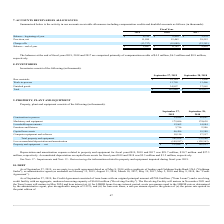According to Macom Technology's financial document, What was the depreciation and amortization expense related to property and equipment for 2019? According to the financial document, $29.7 million. The relevant text states: "equipment for fiscal years 2019, 2018 and 2017 was $29.7 million, $30.7 million and $27.3..." Also, What was the respective value of construction in process in 2019 and 2018? The document shows two values: 24,848 and 49,661 (in thousands). From the document: "Construction in process 24,848 49,661 Construction in process 24,848 49,661..." Also, What was the value of Machinery and equipment in 2019? According to the financial document, 175,696 (in thousands). The relevant text states: "Machinery and equipment 175,696 174,638..." Additionally, In which year was value of Construction in process less than 30,000 thousands? According to the financial document, 2019. The relevant text states: "2019 2018 2017..." Also, can you calculate: What was the average value of Machinery and equipment for 2018 and 2019? To answer this question, I need to perform calculations using the financial data. The calculation is: (175,696 + 174,638) / 2, which equals 175167 (in thousands). This is based on the information: "Machinery and equipment 175,696 174,638 Machinery and equipment 175,696 174,638..." The key data points involved are: 174,638, 175,696. Also, can you calculate: What is the change in the Leasehold improvements from 2018 to 2019? Based on the calculation: 12,962 - 14,984, the result is -2022 (in thousands). This is based on the information: "Leasehold improvements 12,962 14,984 Leasehold improvements 12,962 14,984..." The key data points involved are: 12,962, 14,984. 